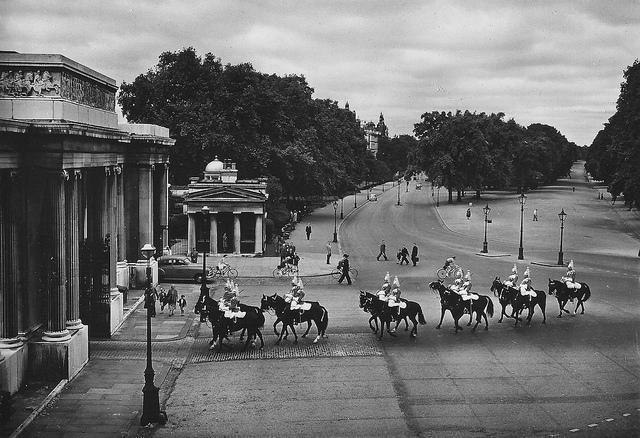How many horses are there?
Give a very brief answer. 11. How many bears are in the chair?
Give a very brief answer. 0. 